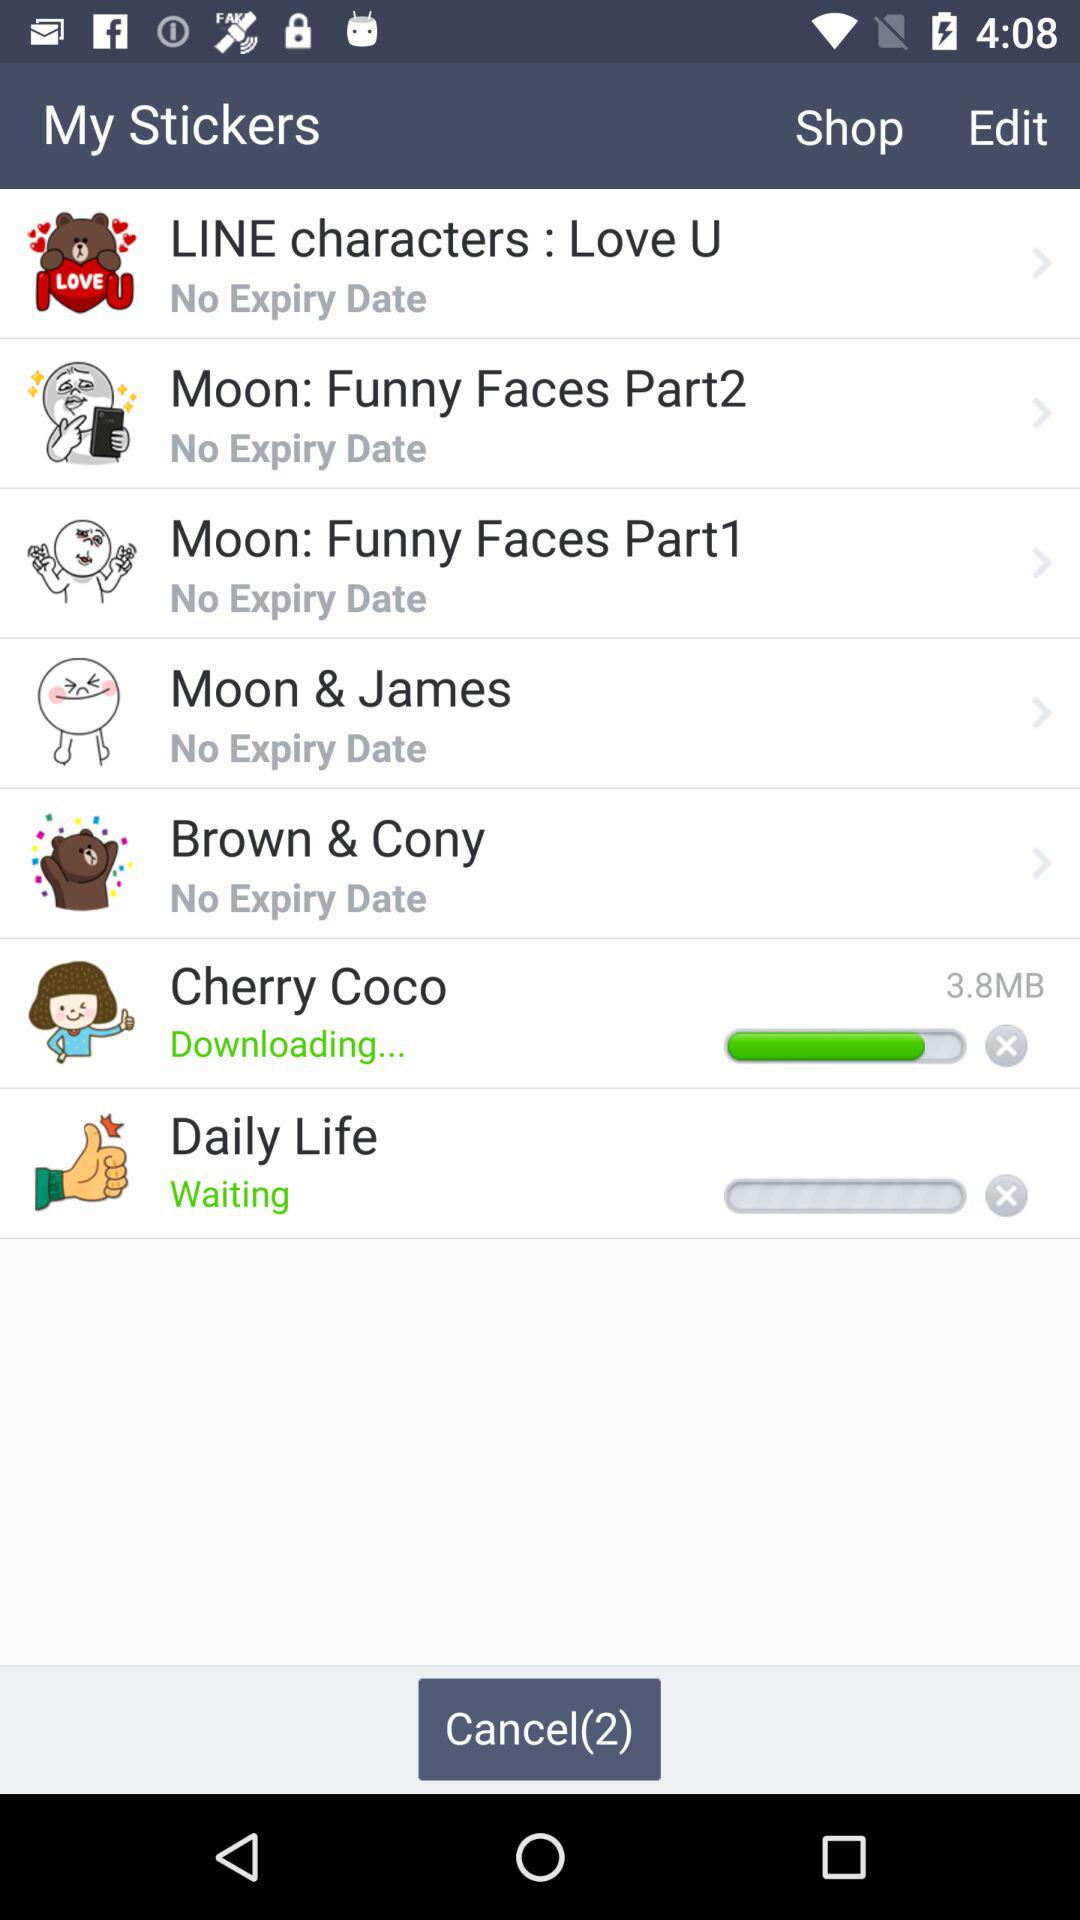What sticker is waiting to be downloaded? The sticker that is waiting to be downloaded is "Daily Life". 